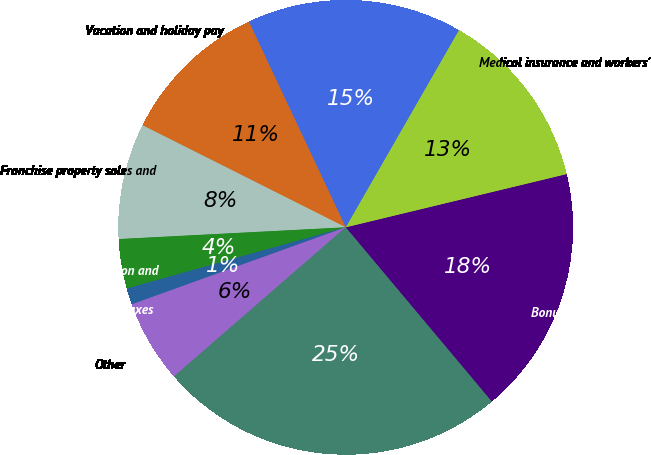Convert chart to OTSL. <chart><loc_0><loc_0><loc_500><loc_500><pie_chart><fcel>Bonuses and incentives and<fcel>Medical insurance and workers'<fcel>Customer volume discounts and<fcel>Vacation and holiday pay<fcel>Franchise property sales and<fcel>Current portion of pension and<fcel>Payroll and payroll taxes<fcel>Other<fcel>Total<nl><fcel>17.66%<fcel>12.94%<fcel>15.3%<fcel>10.59%<fcel>8.23%<fcel>3.52%<fcel>1.16%<fcel>5.88%<fcel>24.72%<nl></chart> 